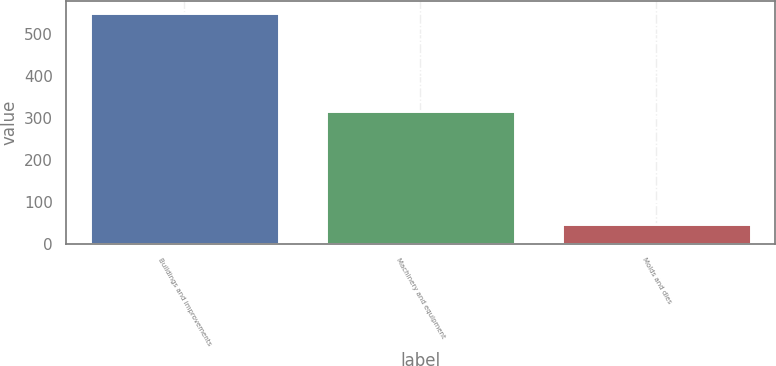<chart> <loc_0><loc_0><loc_500><loc_500><bar_chart><fcel>Buildings and improvements<fcel>Machinery and equipment<fcel>Molds and dies<nl><fcel>550<fcel>315<fcel>47<nl></chart> 